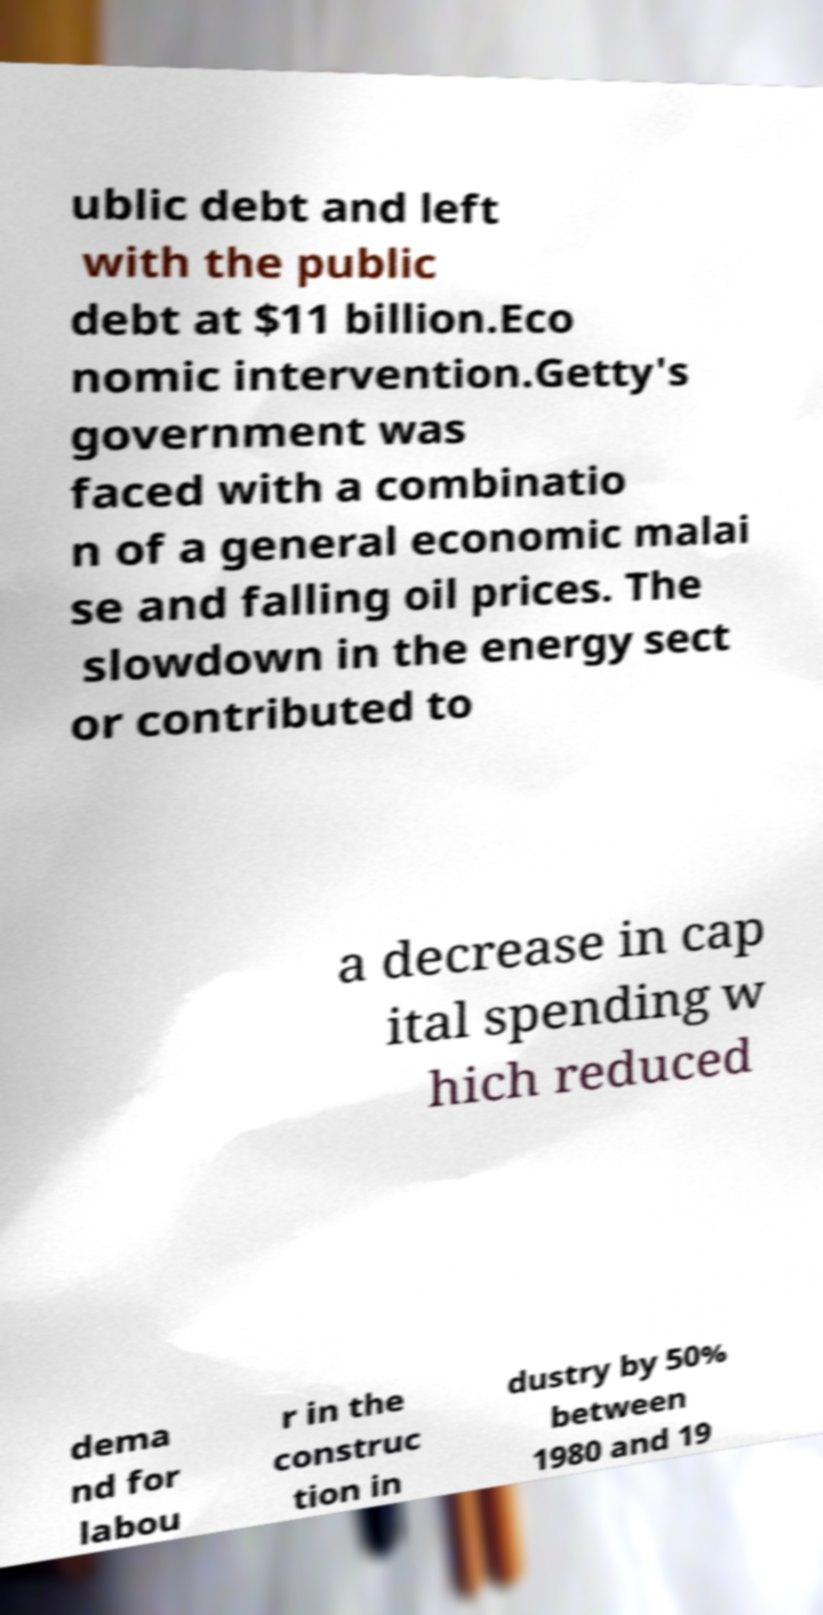I need the written content from this picture converted into text. Can you do that? ublic debt and left with the public debt at $11 billion.Eco nomic intervention.Getty's government was faced with a combinatio n of a general economic malai se and falling oil prices. The slowdown in the energy sect or contributed to a decrease in cap ital spending w hich reduced dema nd for labou r in the construc tion in dustry by 50% between 1980 and 19 